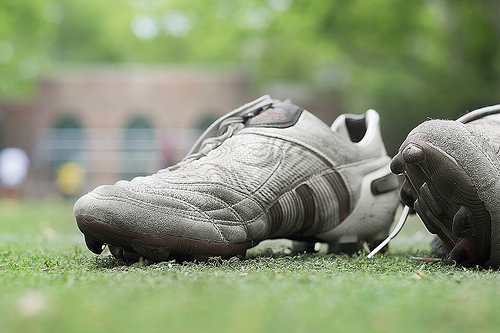<image>
Is there a shoe on the ground? Yes. Looking at the image, I can see the shoe is positioned on top of the ground, with the ground providing support. 